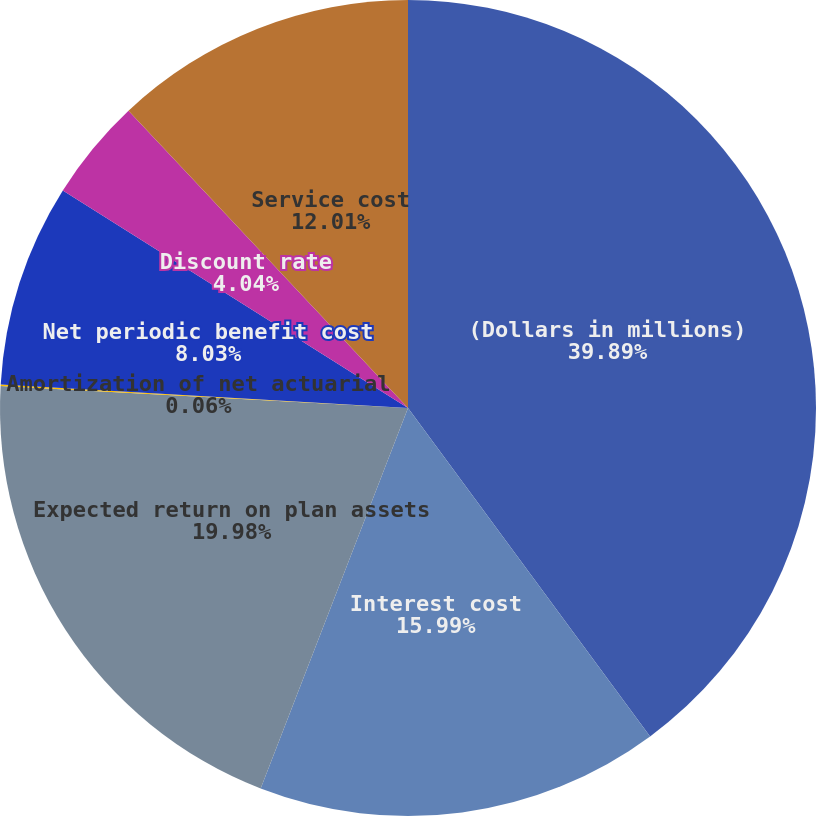<chart> <loc_0><loc_0><loc_500><loc_500><pie_chart><fcel>(Dollars in millions)<fcel>Interest cost<fcel>Expected return on plan assets<fcel>Amortization of net actuarial<fcel>Net periodic benefit cost<fcel>Discount rate<fcel>Service cost<nl><fcel>39.89%<fcel>15.99%<fcel>19.98%<fcel>0.06%<fcel>8.03%<fcel>4.04%<fcel>12.01%<nl></chart> 